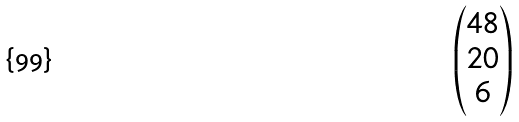<formula> <loc_0><loc_0><loc_500><loc_500>\begin{pmatrix} 4 8 \\ 2 0 \\ 6 \end{pmatrix}</formula> 